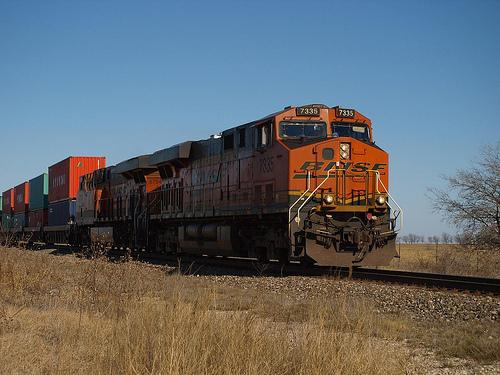Enumerate the focal point of the image and its essential aspects. The image's focal point is a red train engine with a yellow headlight, situated on brown tracks, and surrounded by a blue sky. State the main object and its notable features in the image.  A red freight train on tracks has a yellow headlight, containers, and a blue sky overhead. Highlight the main focus of the image and elaborate on its crucial features. The image focuses on a red train engine surrounded by yellow grass and a blue sky, showcasing its yellow headlight and containers. Mention the primary subject present in the image, along with its key attributes. The dominant subject is a red train engine with stacked containers and a yellow headlight, situated on brown tracks. Identify the most prominent object in the image and describe its significant characteristics. The red train engine, standing out against a blue sky and brown tracks, has a yellow headlight and stacked containers. Write a short description of the main object in the image along with its distinctive properties. This red train engine, featured under a blue sky and on brown tracks, has a yellow headlight and is carrying containers. Provide a brief overview of the primary subject and its surroundings in the image. A red train engine is on brown tracks surrounded by yellow grass and blue sky with trees in the distance. Explain the main subject shown in the image and note its distinguishing qualities. The image displays a red train engine with a yellow headlight, carrying containers, moving on brown tracks under a blue sky. Describe what you primarily see in the image, including any important details. The primary focus is a red train engine on brown tracks with a yellow headlight, blue sky, and trees in the background. Narrate the central object in the image along with its primary aspects. A red freight train on brown tracks dominates the image, with a yellow headlight, stacked containers, and a blue sky above. 